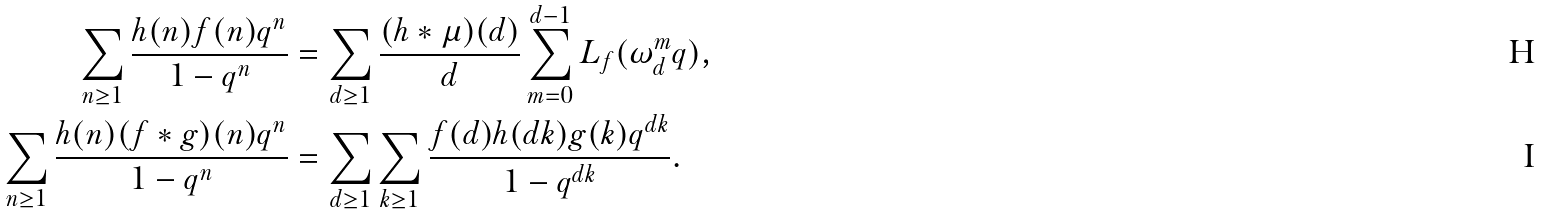<formula> <loc_0><loc_0><loc_500><loc_500>\sum _ { n \geq 1 } \frac { h ( n ) f ( n ) q ^ { n } } { 1 - q ^ { n } } & = \sum _ { d \geq 1 } \frac { ( h \ast \mu ) ( d ) } { d } \sum _ { m = 0 } ^ { d - 1 } L _ { f } ( \omega _ { d } ^ { m } q ) , \\ \sum _ { n \geq 1 } \frac { h ( n ) ( f \ast g ) ( n ) q ^ { n } } { 1 - q ^ { n } } & = \sum _ { d \geq 1 } \sum _ { k \geq 1 } \frac { f ( d ) h ( d k ) g ( k ) q ^ { d k } } { 1 - q ^ { d k } } .</formula> 